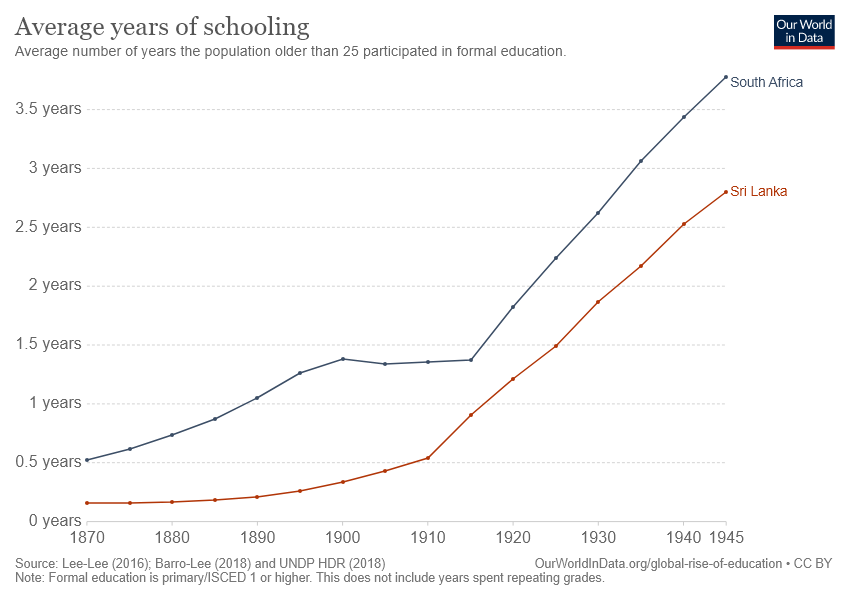Specify some key components in this picture. There are two countries depicted in the graph. The number of data points in the Sri Lanka graph with values greater than 1.5 years is 4. 